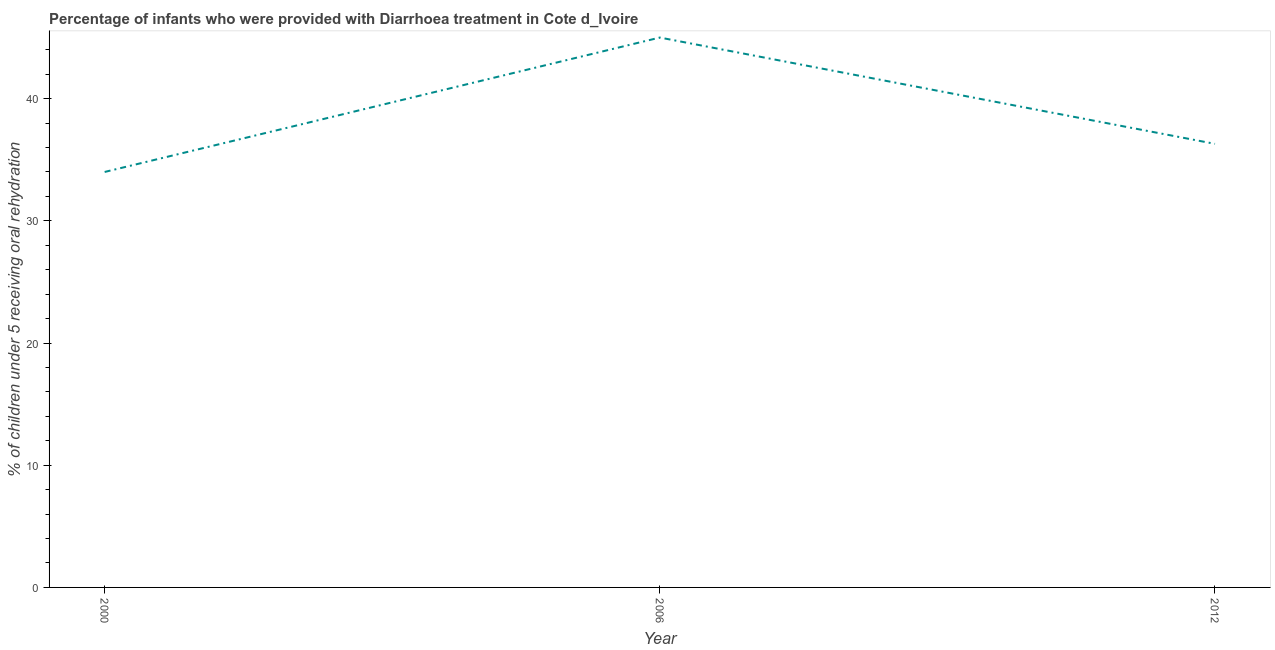What is the percentage of children who were provided with treatment diarrhoea in 2012?
Give a very brief answer. 36.3. Across all years, what is the minimum percentage of children who were provided with treatment diarrhoea?
Ensure brevity in your answer.  34. In which year was the percentage of children who were provided with treatment diarrhoea maximum?
Offer a terse response. 2006. In which year was the percentage of children who were provided with treatment diarrhoea minimum?
Give a very brief answer. 2000. What is the sum of the percentage of children who were provided with treatment diarrhoea?
Your answer should be compact. 115.3. What is the difference between the percentage of children who were provided with treatment diarrhoea in 2006 and 2012?
Ensure brevity in your answer.  8.7. What is the average percentage of children who were provided with treatment diarrhoea per year?
Keep it short and to the point. 38.43. What is the median percentage of children who were provided with treatment diarrhoea?
Give a very brief answer. 36.3. In how many years, is the percentage of children who were provided with treatment diarrhoea greater than 34 %?
Keep it short and to the point. 2. What is the ratio of the percentage of children who were provided with treatment diarrhoea in 2000 to that in 2012?
Offer a terse response. 0.94. Is the percentage of children who were provided with treatment diarrhoea in 2000 less than that in 2012?
Offer a very short reply. Yes. What is the difference between the highest and the second highest percentage of children who were provided with treatment diarrhoea?
Give a very brief answer. 8.7. What is the difference between the highest and the lowest percentage of children who were provided with treatment diarrhoea?
Provide a succinct answer. 11. Does the percentage of children who were provided with treatment diarrhoea monotonically increase over the years?
Ensure brevity in your answer.  No. How many lines are there?
Make the answer very short. 1. What is the difference between two consecutive major ticks on the Y-axis?
Your answer should be compact. 10. What is the title of the graph?
Make the answer very short. Percentage of infants who were provided with Diarrhoea treatment in Cote d_Ivoire. What is the label or title of the X-axis?
Offer a terse response. Year. What is the label or title of the Y-axis?
Offer a very short reply. % of children under 5 receiving oral rehydration. What is the % of children under 5 receiving oral rehydration of 2012?
Offer a very short reply. 36.3. What is the difference between the % of children under 5 receiving oral rehydration in 2000 and 2006?
Offer a terse response. -11. What is the ratio of the % of children under 5 receiving oral rehydration in 2000 to that in 2006?
Keep it short and to the point. 0.76. What is the ratio of the % of children under 5 receiving oral rehydration in 2000 to that in 2012?
Provide a succinct answer. 0.94. What is the ratio of the % of children under 5 receiving oral rehydration in 2006 to that in 2012?
Your answer should be very brief. 1.24. 